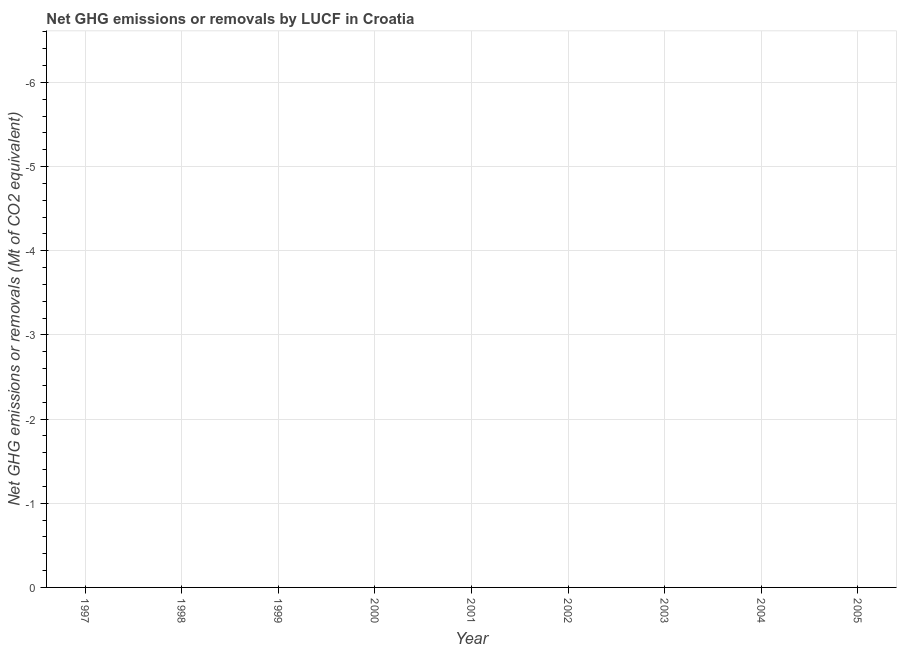What is the median ghg net emissions or removals?
Offer a terse response. 0. In how many years, is the ghg net emissions or removals greater than -2.6 Mt?
Your answer should be very brief. 0. How many lines are there?
Provide a succinct answer. 0. How many years are there in the graph?
Make the answer very short. 9. Does the graph contain grids?
Your response must be concise. Yes. What is the title of the graph?
Offer a very short reply. Net GHG emissions or removals by LUCF in Croatia. What is the label or title of the Y-axis?
Provide a succinct answer. Net GHG emissions or removals (Mt of CO2 equivalent). What is the Net GHG emissions or removals (Mt of CO2 equivalent) of 1999?
Your answer should be compact. 0. What is the Net GHG emissions or removals (Mt of CO2 equivalent) of 2003?
Offer a very short reply. 0. What is the Net GHG emissions or removals (Mt of CO2 equivalent) in 2005?
Give a very brief answer. 0. 